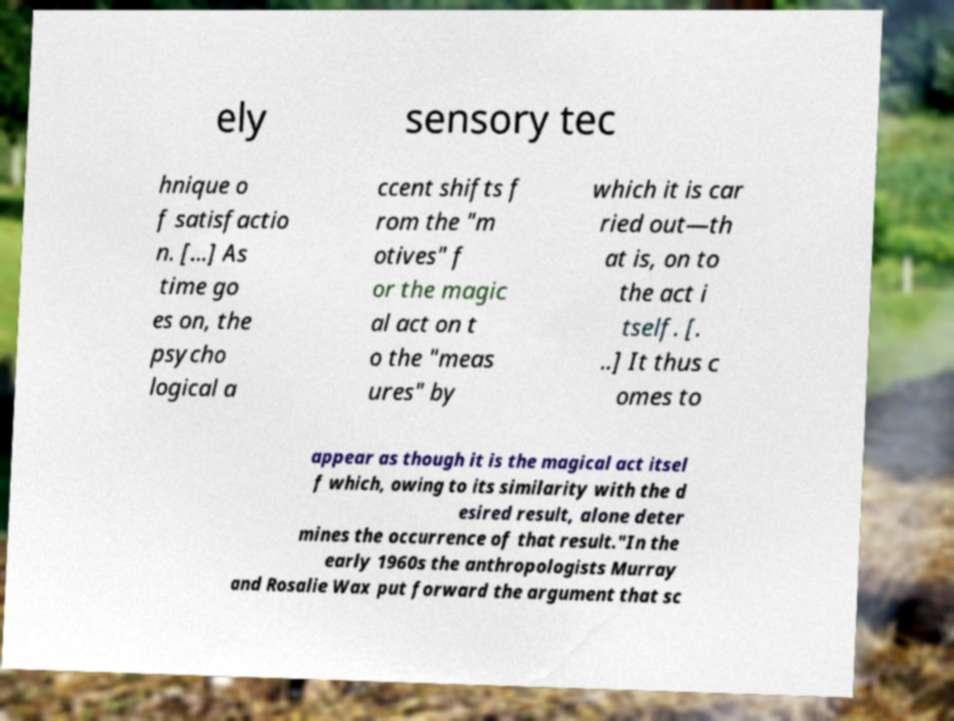What messages or text are displayed in this image? I need them in a readable, typed format. ely sensory tec hnique o f satisfactio n. [...] As time go es on, the psycho logical a ccent shifts f rom the "m otives" f or the magic al act on t o the "meas ures" by which it is car ried out—th at is, on to the act i tself. [. ..] It thus c omes to appear as though it is the magical act itsel f which, owing to its similarity with the d esired result, alone deter mines the occurrence of that result."In the early 1960s the anthropologists Murray and Rosalie Wax put forward the argument that sc 